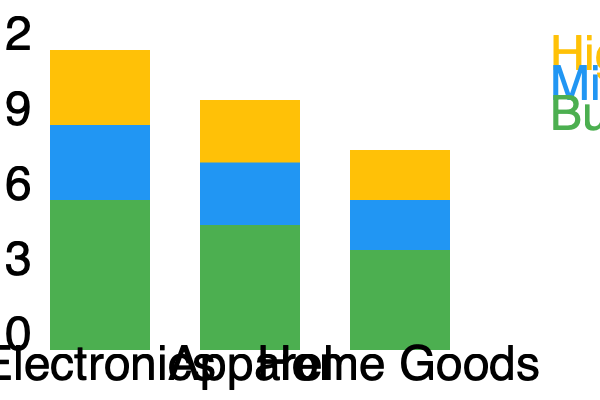As an eCommerce business owner concerned with data-driven decisions, you're analyzing the inventory turnover rates for different product lines and price segments. The stacked bar chart shows the annual inventory turnover rates for three product categories (Electronics, Apparel, and Home Goods) across three price segments (High-end, Mid-range, and Budget). Given this data, which product category has the highest overall inventory turnover rate, and what potential implications does this have for your inventory management strategy? To determine the product category with the highest overall inventory turnover rate, we need to sum up the rates for each price segment within each category:

1. Electronics:
   High-end: 3
   Mid-range: 3
   Budget: 6
   Total: $3 + 3 + 6 = 12$

2. Apparel:
   High-end: 2.5
   Mid-range: 2.5
   Budget: 5
   Total: $2.5 + 2.5 + 5 = 10$

3. Home Goods:
   High-end: 2
   Mid-range: 2
   Budget: 4
   Total: $2 + 2 + 4 = 8$

Electronics has the highest overall inventory turnover rate at 12 turns per year.

Implications for inventory management strategy:

1. Cash flow: Higher turnover in Electronics suggests faster conversion of inventory to cash, which could improve liquidity.

2. Storage costs: Electronics may require less storage space relative to sales, potentially reducing warehousing costs.

3. Restocking frequency: More frequent restocking may be necessary for Electronics, requiring efficient supply chain management.

4. Inventory risk: Lower risk of obsolescence or depreciation for Electronics due to faster turnover.

5. Pricing strategy: The high turnover in Electronics, especially in the budget segment, might indicate an opportunity for slight price increases without significantly impacting sales velocity.

6. Category focus: Consider allocating more resources or expanding the Electronics category given its strong performance.

7. Cross-category analysis: Investigate why Home Goods have a lower turnover rate and whether strategies from Electronics can be applied to improve performance.

8. Segmentation strategy: The data shows that budget items consistently have higher turnover rates across categories, which might inform future purchasing and marketing decisions.

This data-driven approach allows for more predictable inventory management, aligning with the persona's preference for data while minimizing surprises in stock levels and cash flow.
Answer: Electronics; implies potential for improved cash flow, reduced storage costs, need for efficient restocking, lower obsolescence risk, and possible pricing adjustments. 